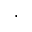Convert formula to latex. <formula><loc_0><loc_0><loc_500><loc_500>\cdot</formula> 